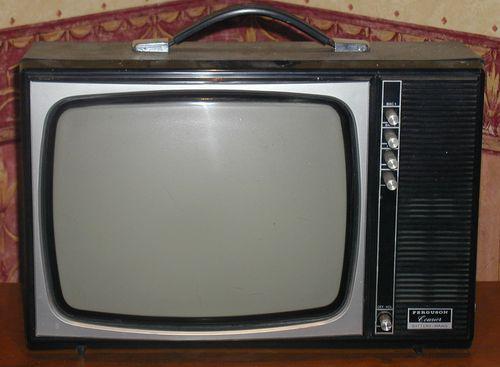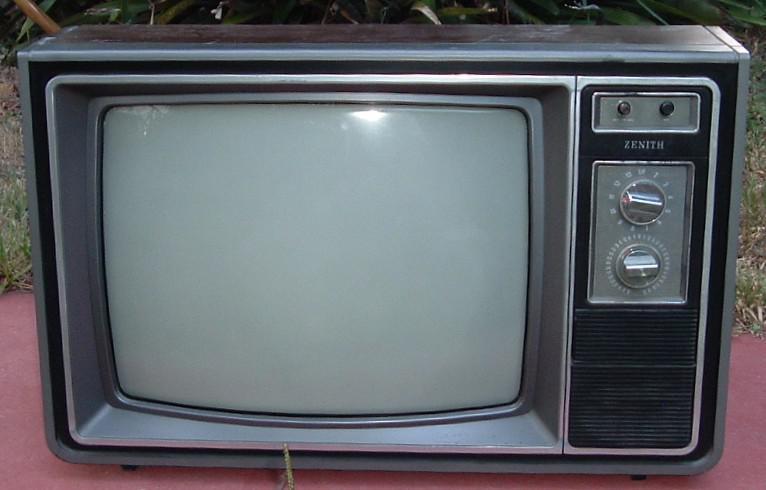The first image is the image on the left, the second image is the image on the right. Assess this claim about the two images: "The right image contains a TV with a reddish-orange case and two large dials to the right of its screen.". Correct or not? Answer yes or no. No. The first image is the image on the left, the second image is the image on the right. Analyze the images presented: Is the assertion "In one of the images there is a red television with rotary knobs." valid? Answer yes or no. No. 